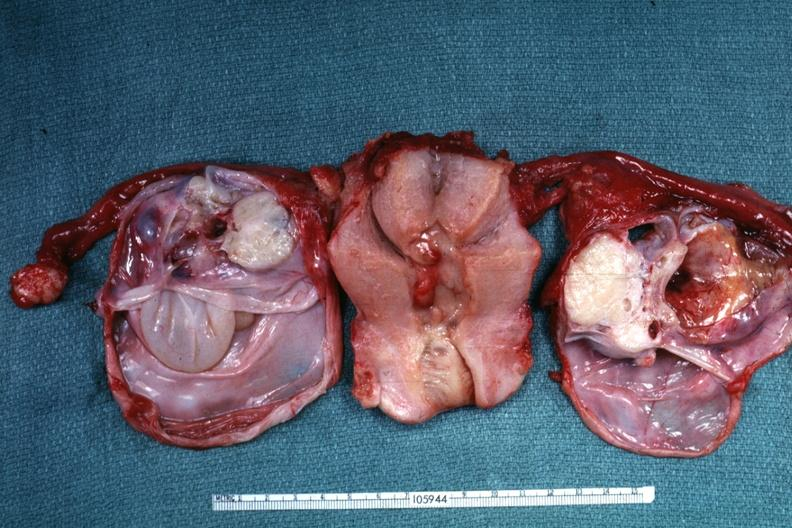does this image show same as except ovaries have been cut to show multiloculated nature of tumor masses?
Answer the question using a single word or phrase. Yes 